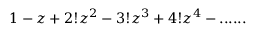Convert formula to latex. <formula><loc_0><loc_0><loc_500><loc_500>1 - z + 2 ! z ^ { 2 } - 3 ! z ^ { 3 } + 4 ! z ^ { 4 } - \cdots . .</formula> 